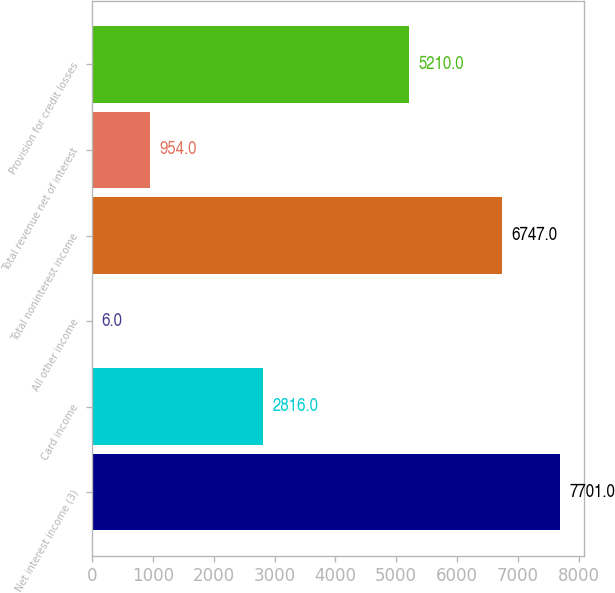Convert chart. <chart><loc_0><loc_0><loc_500><loc_500><bar_chart><fcel>Net interest income (3)<fcel>Card income<fcel>All other income<fcel>Total noninterest income<fcel>Total revenue net of interest<fcel>Provision for credit losses<nl><fcel>7701<fcel>2816<fcel>6<fcel>6747<fcel>954<fcel>5210<nl></chart> 